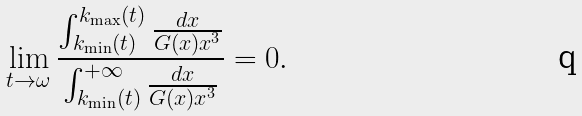Convert formula to latex. <formula><loc_0><loc_0><loc_500><loc_500>\lim _ { t \rightarrow \omega } \frac { \int ^ { k _ { \max } ( t ) } _ { k _ { \min } ( t ) } \frac { d x } { G ( x ) x ^ { 3 } } } { \int ^ { + \infty } _ { k _ { \min } ( t ) } \frac { d x } { G ( x ) x ^ { 3 } } } = 0 .</formula> 